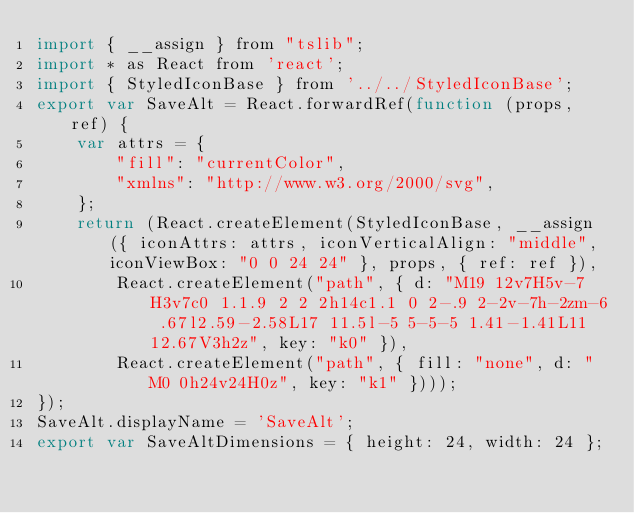Convert code to text. <code><loc_0><loc_0><loc_500><loc_500><_JavaScript_>import { __assign } from "tslib";
import * as React from 'react';
import { StyledIconBase } from '../../StyledIconBase';
export var SaveAlt = React.forwardRef(function (props, ref) {
    var attrs = {
        "fill": "currentColor",
        "xmlns": "http://www.w3.org/2000/svg",
    };
    return (React.createElement(StyledIconBase, __assign({ iconAttrs: attrs, iconVerticalAlign: "middle", iconViewBox: "0 0 24 24" }, props, { ref: ref }),
        React.createElement("path", { d: "M19 12v7H5v-7H3v7c0 1.1.9 2 2 2h14c1.1 0 2-.9 2-2v-7h-2zm-6 .67l2.59-2.58L17 11.5l-5 5-5-5 1.41-1.41L11 12.67V3h2z", key: "k0" }),
        React.createElement("path", { fill: "none", d: "M0 0h24v24H0z", key: "k1" })));
});
SaveAlt.displayName = 'SaveAlt';
export var SaveAltDimensions = { height: 24, width: 24 };
</code> 